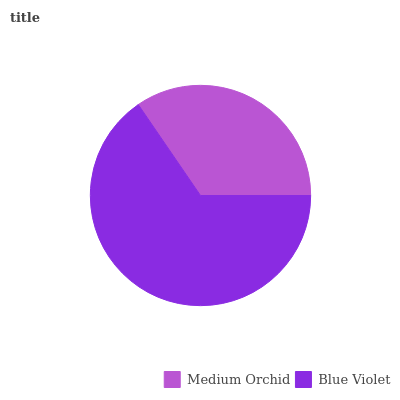Is Medium Orchid the minimum?
Answer yes or no. Yes. Is Blue Violet the maximum?
Answer yes or no. Yes. Is Blue Violet the minimum?
Answer yes or no. No. Is Blue Violet greater than Medium Orchid?
Answer yes or no. Yes. Is Medium Orchid less than Blue Violet?
Answer yes or no. Yes. Is Medium Orchid greater than Blue Violet?
Answer yes or no. No. Is Blue Violet less than Medium Orchid?
Answer yes or no. No. Is Blue Violet the high median?
Answer yes or no. Yes. Is Medium Orchid the low median?
Answer yes or no. Yes. Is Medium Orchid the high median?
Answer yes or no. No. Is Blue Violet the low median?
Answer yes or no. No. 